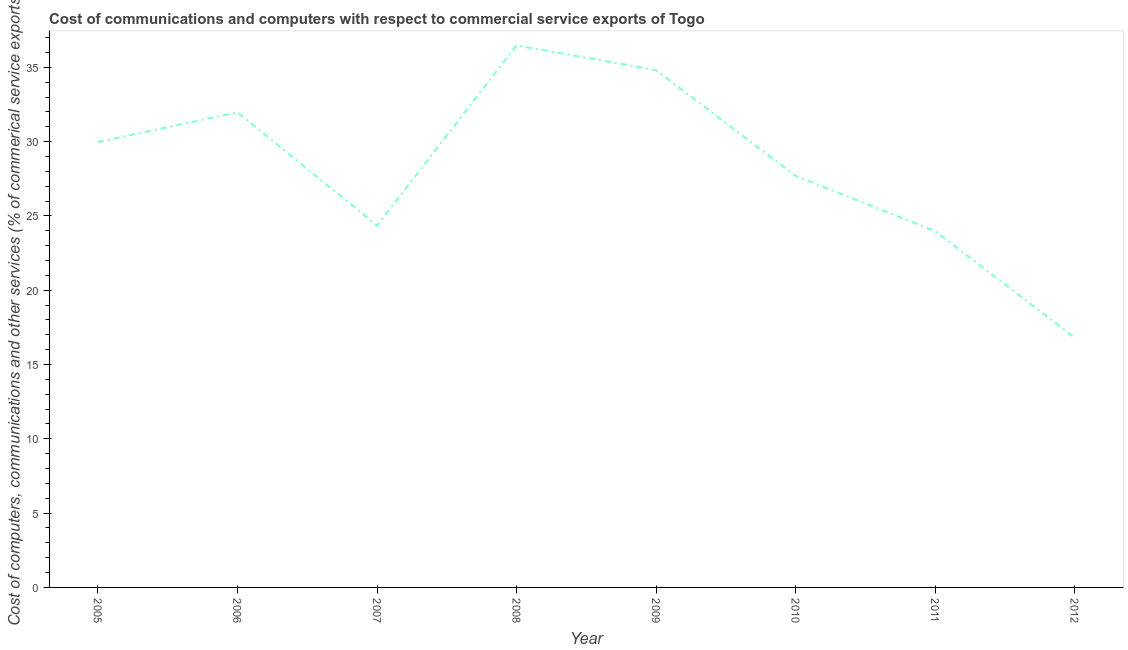What is the cost of communications in 2011?
Your answer should be very brief. 23.98. Across all years, what is the maximum cost of communications?
Give a very brief answer. 36.48. Across all years, what is the minimum cost of communications?
Offer a terse response. 16.82. In which year was the cost of communications maximum?
Keep it short and to the point. 2008. In which year was the  computer and other services minimum?
Make the answer very short. 2012. What is the sum of the  computer and other services?
Keep it short and to the point. 226.1. What is the difference between the cost of communications in 2011 and 2012?
Offer a very short reply. 7.16. What is the average cost of communications per year?
Ensure brevity in your answer.  28.26. What is the median  computer and other services?
Make the answer very short. 28.84. In how many years, is the  computer and other services greater than 16 %?
Make the answer very short. 8. Do a majority of the years between 2005 and 2008 (inclusive) have cost of communications greater than 31 %?
Offer a very short reply. No. What is the ratio of the cost of communications in 2006 to that in 2007?
Your answer should be compact. 1.31. What is the difference between the highest and the second highest cost of communications?
Give a very brief answer. 1.66. What is the difference between the highest and the lowest cost of communications?
Your response must be concise. 19.66. In how many years, is the  computer and other services greater than the average  computer and other services taken over all years?
Offer a terse response. 4. How many years are there in the graph?
Offer a very short reply. 8. Are the values on the major ticks of Y-axis written in scientific E-notation?
Ensure brevity in your answer.  No. What is the title of the graph?
Ensure brevity in your answer.  Cost of communications and computers with respect to commercial service exports of Togo. What is the label or title of the Y-axis?
Provide a succinct answer. Cost of computers, communications and other services (% of commerical service exports). What is the Cost of computers, communications and other services (% of commerical service exports) of 2005?
Provide a succinct answer. 29.98. What is the Cost of computers, communications and other services (% of commerical service exports) of 2006?
Ensure brevity in your answer.  31.98. What is the Cost of computers, communications and other services (% of commerical service exports) of 2007?
Make the answer very short. 24.35. What is the Cost of computers, communications and other services (% of commerical service exports) in 2008?
Offer a terse response. 36.48. What is the Cost of computers, communications and other services (% of commerical service exports) in 2009?
Provide a succinct answer. 34.82. What is the Cost of computers, communications and other services (% of commerical service exports) in 2010?
Ensure brevity in your answer.  27.7. What is the Cost of computers, communications and other services (% of commerical service exports) in 2011?
Make the answer very short. 23.98. What is the Cost of computers, communications and other services (% of commerical service exports) in 2012?
Offer a very short reply. 16.82. What is the difference between the Cost of computers, communications and other services (% of commerical service exports) in 2005 and 2006?
Your response must be concise. -2. What is the difference between the Cost of computers, communications and other services (% of commerical service exports) in 2005 and 2007?
Your response must be concise. 5.63. What is the difference between the Cost of computers, communications and other services (% of commerical service exports) in 2005 and 2008?
Offer a very short reply. -6.5. What is the difference between the Cost of computers, communications and other services (% of commerical service exports) in 2005 and 2009?
Keep it short and to the point. -4.84. What is the difference between the Cost of computers, communications and other services (% of commerical service exports) in 2005 and 2010?
Provide a short and direct response. 2.28. What is the difference between the Cost of computers, communications and other services (% of commerical service exports) in 2005 and 2011?
Offer a terse response. 6. What is the difference between the Cost of computers, communications and other services (% of commerical service exports) in 2005 and 2012?
Provide a succinct answer. 13.16. What is the difference between the Cost of computers, communications and other services (% of commerical service exports) in 2006 and 2007?
Make the answer very short. 7.63. What is the difference between the Cost of computers, communications and other services (% of commerical service exports) in 2006 and 2008?
Your response must be concise. -4.5. What is the difference between the Cost of computers, communications and other services (% of commerical service exports) in 2006 and 2009?
Ensure brevity in your answer.  -2.84. What is the difference between the Cost of computers, communications and other services (% of commerical service exports) in 2006 and 2010?
Your response must be concise. 4.28. What is the difference between the Cost of computers, communications and other services (% of commerical service exports) in 2006 and 2011?
Provide a short and direct response. 8. What is the difference between the Cost of computers, communications and other services (% of commerical service exports) in 2006 and 2012?
Offer a terse response. 15.16. What is the difference between the Cost of computers, communications and other services (% of commerical service exports) in 2007 and 2008?
Provide a succinct answer. -12.13. What is the difference between the Cost of computers, communications and other services (% of commerical service exports) in 2007 and 2009?
Offer a terse response. -10.47. What is the difference between the Cost of computers, communications and other services (% of commerical service exports) in 2007 and 2010?
Keep it short and to the point. -3.35. What is the difference between the Cost of computers, communications and other services (% of commerical service exports) in 2007 and 2011?
Offer a very short reply. 0.37. What is the difference between the Cost of computers, communications and other services (% of commerical service exports) in 2007 and 2012?
Make the answer very short. 7.53. What is the difference between the Cost of computers, communications and other services (% of commerical service exports) in 2008 and 2009?
Keep it short and to the point. 1.66. What is the difference between the Cost of computers, communications and other services (% of commerical service exports) in 2008 and 2010?
Your answer should be very brief. 8.78. What is the difference between the Cost of computers, communications and other services (% of commerical service exports) in 2008 and 2011?
Make the answer very short. 12.5. What is the difference between the Cost of computers, communications and other services (% of commerical service exports) in 2008 and 2012?
Provide a short and direct response. 19.66. What is the difference between the Cost of computers, communications and other services (% of commerical service exports) in 2009 and 2010?
Provide a short and direct response. 7.12. What is the difference between the Cost of computers, communications and other services (% of commerical service exports) in 2009 and 2011?
Your response must be concise. 10.84. What is the difference between the Cost of computers, communications and other services (% of commerical service exports) in 2009 and 2012?
Your answer should be very brief. 18. What is the difference between the Cost of computers, communications and other services (% of commerical service exports) in 2010 and 2011?
Provide a succinct answer. 3.72. What is the difference between the Cost of computers, communications and other services (% of commerical service exports) in 2010 and 2012?
Provide a short and direct response. 10.88. What is the difference between the Cost of computers, communications and other services (% of commerical service exports) in 2011 and 2012?
Ensure brevity in your answer.  7.16. What is the ratio of the Cost of computers, communications and other services (% of commerical service exports) in 2005 to that in 2006?
Provide a succinct answer. 0.94. What is the ratio of the Cost of computers, communications and other services (% of commerical service exports) in 2005 to that in 2007?
Give a very brief answer. 1.23. What is the ratio of the Cost of computers, communications and other services (% of commerical service exports) in 2005 to that in 2008?
Make the answer very short. 0.82. What is the ratio of the Cost of computers, communications and other services (% of commerical service exports) in 2005 to that in 2009?
Make the answer very short. 0.86. What is the ratio of the Cost of computers, communications and other services (% of commerical service exports) in 2005 to that in 2010?
Your answer should be very brief. 1.08. What is the ratio of the Cost of computers, communications and other services (% of commerical service exports) in 2005 to that in 2011?
Make the answer very short. 1.25. What is the ratio of the Cost of computers, communications and other services (% of commerical service exports) in 2005 to that in 2012?
Provide a short and direct response. 1.78. What is the ratio of the Cost of computers, communications and other services (% of commerical service exports) in 2006 to that in 2007?
Your answer should be very brief. 1.31. What is the ratio of the Cost of computers, communications and other services (% of commerical service exports) in 2006 to that in 2008?
Your answer should be compact. 0.88. What is the ratio of the Cost of computers, communications and other services (% of commerical service exports) in 2006 to that in 2009?
Offer a very short reply. 0.92. What is the ratio of the Cost of computers, communications and other services (% of commerical service exports) in 2006 to that in 2010?
Offer a very short reply. 1.15. What is the ratio of the Cost of computers, communications and other services (% of commerical service exports) in 2006 to that in 2011?
Keep it short and to the point. 1.33. What is the ratio of the Cost of computers, communications and other services (% of commerical service exports) in 2006 to that in 2012?
Keep it short and to the point. 1.9. What is the ratio of the Cost of computers, communications and other services (% of commerical service exports) in 2007 to that in 2008?
Offer a terse response. 0.67. What is the ratio of the Cost of computers, communications and other services (% of commerical service exports) in 2007 to that in 2009?
Give a very brief answer. 0.7. What is the ratio of the Cost of computers, communications and other services (% of commerical service exports) in 2007 to that in 2010?
Your answer should be very brief. 0.88. What is the ratio of the Cost of computers, communications and other services (% of commerical service exports) in 2007 to that in 2012?
Your response must be concise. 1.45. What is the ratio of the Cost of computers, communications and other services (% of commerical service exports) in 2008 to that in 2009?
Give a very brief answer. 1.05. What is the ratio of the Cost of computers, communications and other services (% of commerical service exports) in 2008 to that in 2010?
Give a very brief answer. 1.32. What is the ratio of the Cost of computers, communications and other services (% of commerical service exports) in 2008 to that in 2011?
Provide a succinct answer. 1.52. What is the ratio of the Cost of computers, communications and other services (% of commerical service exports) in 2008 to that in 2012?
Provide a short and direct response. 2.17. What is the ratio of the Cost of computers, communications and other services (% of commerical service exports) in 2009 to that in 2010?
Keep it short and to the point. 1.26. What is the ratio of the Cost of computers, communications and other services (% of commerical service exports) in 2009 to that in 2011?
Give a very brief answer. 1.45. What is the ratio of the Cost of computers, communications and other services (% of commerical service exports) in 2009 to that in 2012?
Your answer should be compact. 2.07. What is the ratio of the Cost of computers, communications and other services (% of commerical service exports) in 2010 to that in 2011?
Your answer should be very brief. 1.16. What is the ratio of the Cost of computers, communications and other services (% of commerical service exports) in 2010 to that in 2012?
Your answer should be very brief. 1.65. What is the ratio of the Cost of computers, communications and other services (% of commerical service exports) in 2011 to that in 2012?
Offer a very short reply. 1.43. 